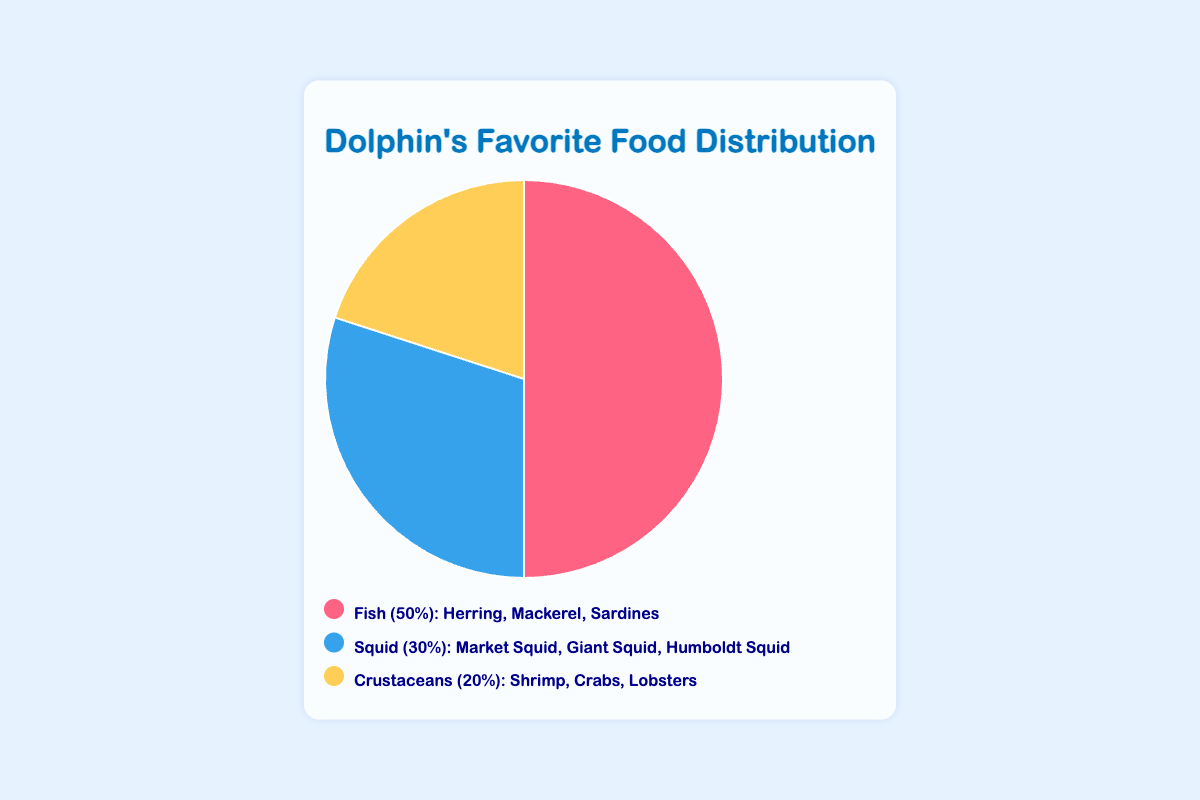What percentage of dolphins’ favorite food is Squid? Look at the figure and identify the percentage associated with Squid. It is shown to be 30%.
Answer: 30% Which type of food is preferred by dolphins more: Fish or Crustaceans? Compare the percentages of Fish and Crustaceans. Fish is 50% and Crustaceans is 20%. Therefore, dolphins prefer Fish more.
Answer: Fish What is the total percentage of dolphins' favorite food that are not Fish? To find this, sum the percentages of Squid and Crustaceans. Squid is 30% and Crustaceans is 20%. So, the total is 30% + 20% = 50%.
Answer: 50% How much more popular is Fish compared to Squid among dolphins? Subtract the percentage of Squid from the percentage of Fish. Fish is 50% and Squid is 30%, so 50% - 30% = 20%.
Answer: 20% Which type of food has the least percentage among dolphins' favorites? Look for the smallest percentage in the pie chart. Crustaceans have the smallest percentage at 20%.
Answer: Crustaceans What is the percentage difference between the most and least preferred food types? Identify the most and least preferred food types. Fish is the most preferred at 50%, and Crustaceans are the least at 20%. The difference is 50% - 20% = 30%.
Answer: 30% If the figure were to include an additional 10% for Crustaceans, what percentage would it then represent? Add the extra 10% to the current percentage of Crustaceans. Crustaceans are at 20%, so 20% + 10% = 30%.
Answer: 30% What are the common species of food associated with Squid? Refer to the legend for the common species listed for Squid. They are Market Squid, Giant Squid, and Humboldt Squid.
Answer: Market Squid, Giant Squid, Humboldt Squid 